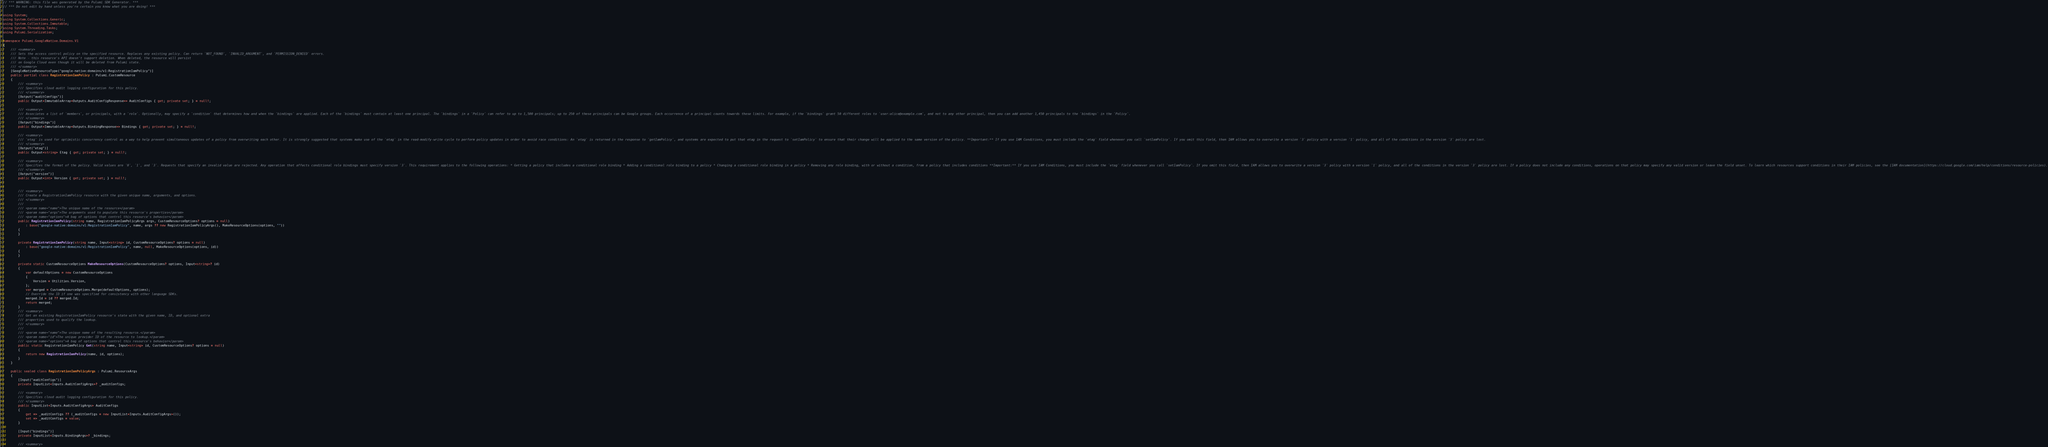<code> <loc_0><loc_0><loc_500><loc_500><_C#_>// *** WARNING: this file was generated by the Pulumi SDK Generator. ***
// *** Do not edit by hand unless you're certain you know what you are doing! ***

using System;
using System.Collections.Generic;
using System.Collections.Immutable;
using System.Threading.Tasks;
using Pulumi.Serialization;

namespace Pulumi.GoogleNative.Domains.V1
{
    /// <summary>
    /// Sets the access control policy on the specified resource. Replaces any existing policy. Can return `NOT_FOUND`, `INVALID_ARGUMENT`, and `PERMISSION_DENIED` errors.
    /// Note - this resource's API doesn't support deletion. When deleted, the resource will persist
    /// on Google Cloud even though it will be deleted from Pulumi state.
    /// </summary>
    [GoogleNativeResourceType("google-native:domains/v1:RegistrationIamPolicy")]
    public partial class RegistrationIamPolicy : Pulumi.CustomResource
    {
        /// <summary>
        /// Specifies cloud audit logging configuration for this policy.
        /// </summary>
        [Output("auditConfigs")]
        public Output<ImmutableArray<Outputs.AuditConfigResponse>> AuditConfigs { get; private set; } = null!;

        /// <summary>
        /// Associates a list of `members`, or principals, with a `role`. Optionally, may specify a `condition` that determines how and when the `bindings` are applied. Each of the `bindings` must contain at least one principal. The `bindings` in a `Policy` can refer to up to 1,500 principals; up to 250 of these principals can be Google groups. Each occurrence of a principal counts towards these limits. For example, if the `bindings` grant 50 different roles to `user:alice@example.com`, and not to any other principal, then you can add another 1,450 principals to the `bindings` in the `Policy`.
        /// </summary>
        [Output("bindings")]
        public Output<ImmutableArray<Outputs.BindingResponse>> Bindings { get; private set; } = null!;

        /// <summary>
        /// `etag` is used for optimistic concurrency control as a way to help prevent simultaneous updates of a policy from overwriting each other. It is strongly suggested that systems make use of the `etag` in the read-modify-write cycle to perform policy updates in order to avoid race conditions: An `etag` is returned in the response to `getIamPolicy`, and systems are expected to put that etag in the request to `setIamPolicy` to ensure that their change will be applied to the same version of the policy. **Important:** If you use IAM Conditions, you must include the `etag` field whenever you call `setIamPolicy`. If you omit this field, then IAM allows you to overwrite a version `3` policy with a version `1` policy, and all of the conditions in the version `3` policy are lost.
        /// </summary>
        [Output("etag")]
        public Output<string> Etag { get; private set; } = null!;

        /// <summary>
        /// Specifies the format of the policy. Valid values are `0`, `1`, and `3`. Requests that specify an invalid value are rejected. Any operation that affects conditional role bindings must specify version `3`. This requirement applies to the following operations: * Getting a policy that includes a conditional role binding * Adding a conditional role binding to a policy * Changing a conditional role binding in a policy * Removing any role binding, with or without a condition, from a policy that includes conditions **Important:** If you use IAM Conditions, you must include the `etag` field whenever you call `setIamPolicy`. If you omit this field, then IAM allows you to overwrite a version `3` policy with a version `1` policy, and all of the conditions in the version `3` policy are lost. If a policy does not include any conditions, operations on that policy may specify any valid version or leave the field unset. To learn which resources support conditions in their IAM policies, see the [IAM documentation](https://cloud.google.com/iam/help/conditions/resource-policies).
        /// </summary>
        [Output("version")]
        public Output<int> Version { get; private set; } = null!;


        /// <summary>
        /// Create a RegistrationIamPolicy resource with the given unique name, arguments, and options.
        /// </summary>
        ///
        /// <param name="name">The unique name of the resource</param>
        /// <param name="args">The arguments used to populate this resource's properties</param>
        /// <param name="options">A bag of options that control this resource's behavior</param>
        public RegistrationIamPolicy(string name, RegistrationIamPolicyArgs args, CustomResourceOptions? options = null)
            : base("google-native:domains/v1:RegistrationIamPolicy", name, args ?? new RegistrationIamPolicyArgs(), MakeResourceOptions(options, ""))
        {
        }

        private RegistrationIamPolicy(string name, Input<string> id, CustomResourceOptions? options = null)
            : base("google-native:domains/v1:RegistrationIamPolicy", name, null, MakeResourceOptions(options, id))
        {
        }

        private static CustomResourceOptions MakeResourceOptions(CustomResourceOptions? options, Input<string>? id)
        {
            var defaultOptions = new CustomResourceOptions
            {
                Version = Utilities.Version,
            };
            var merged = CustomResourceOptions.Merge(defaultOptions, options);
            // Override the ID if one was specified for consistency with other language SDKs.
            merged.Id = id ?? merged.Id;
            return merged;
        }
        /// <summary>
        /// Get an existing RegistrationIamPolicy resource's state with the given name, ID, and optional extra
        /// properties used to qualify the lookup.
        /// </summary>
        ///
        /// <param name="name">The unique name of the resulting resource.</param>
        /// <param name="id">The unique provider ID of the resource to lookup.</param>
        /// <param name="options">A bag of options that control this resource's behavior</param>
        public static RegistrationIamPolicy Get(string name, Input<string> id, CustomResourceOptions? options = null)
        {
            return new RegistrationIamPolicy(name, id, options);
        }
    }

    public sealed class RegistrationIamPolicyArgs : Pulumi.ResourceArgs
    {
        [Input("auditConfigs")]
        private InputList<Inputs.AuditConfigArgs>? _auditConfigs;

        /// <summary>
        /// Specifies cloud audit logging configuration for this policy.
        /// </summary>
        public InputList<Inputs.AuditConfigArgs> AuditConfigs
        {
            get => _auditConfigs ?? (_auditConfigs = new InputList<Inputs.AuditConfigArgs>());
            set => _auditConfigs = value;
        }

        [Input("bindings")]
        private InputList<Inputs.BindingArgs>? _bindings;

        /// <summary></code> 